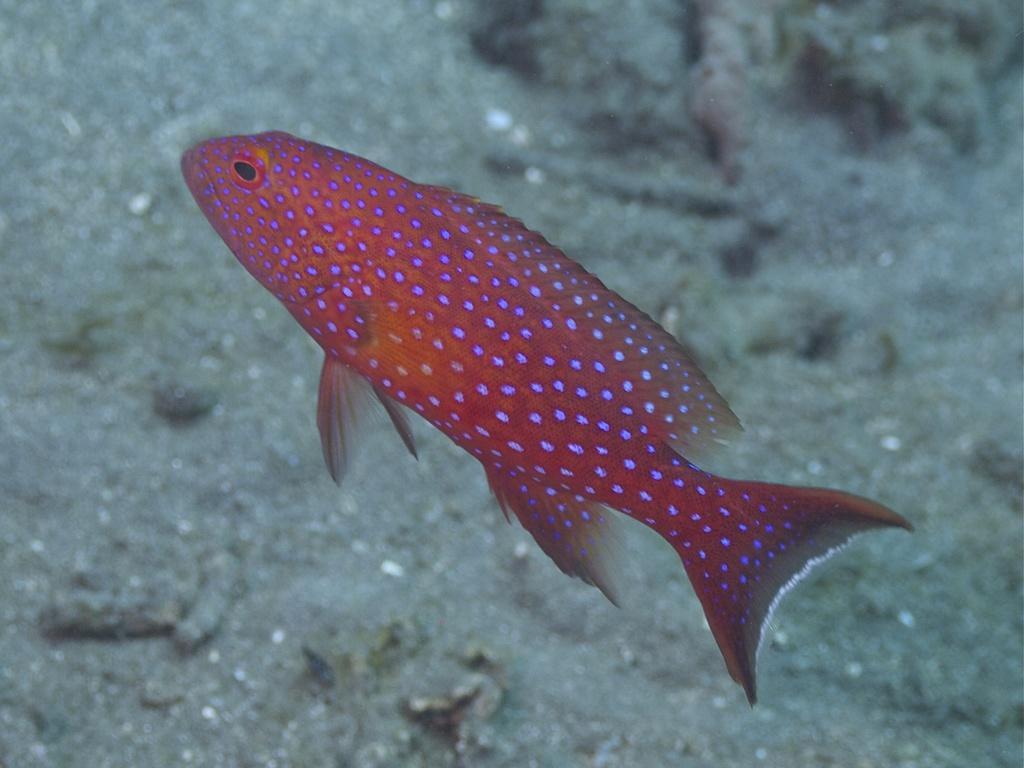Could you give a brief overview of what you see in this image? In this image we can see a fish. Background of the image sand is there. 